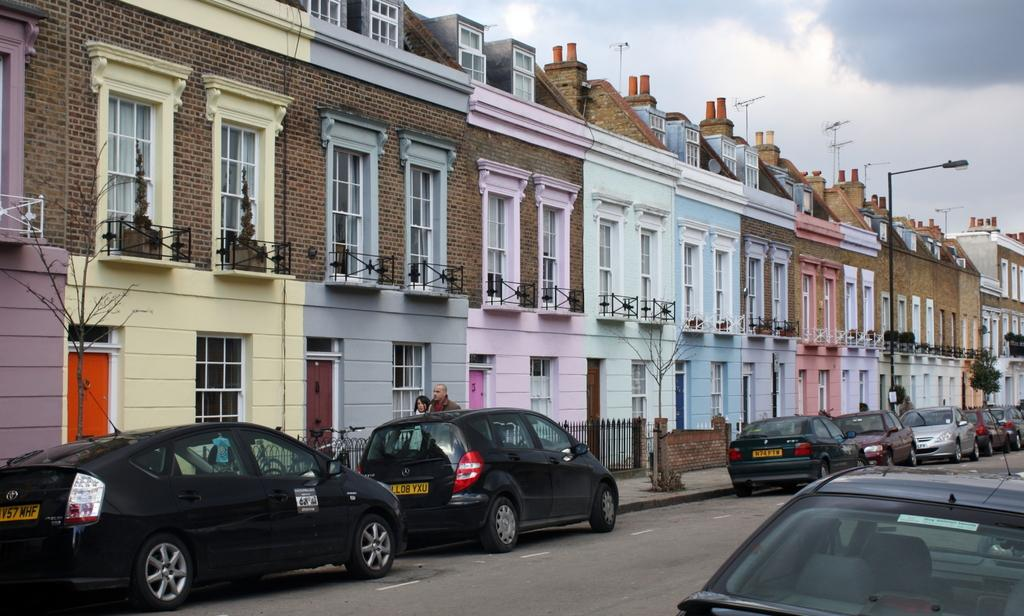What is located in the center of the image? There are buildings, railing, poles, trees, and lights in the center of the image. What type of transportation can be seen on the road in the image? There are vehicles on the road in the image. What is visible at the top of the image? The sky is visible at the top of the image. Can you describe the coil that is wrapped around the trees in the image? There is no coil wrapped around the trees in the image; only buildings, railing, poles, lights, vehicles, and the sky are present. What are the girls doing in the image? There are no girls present in the image. 